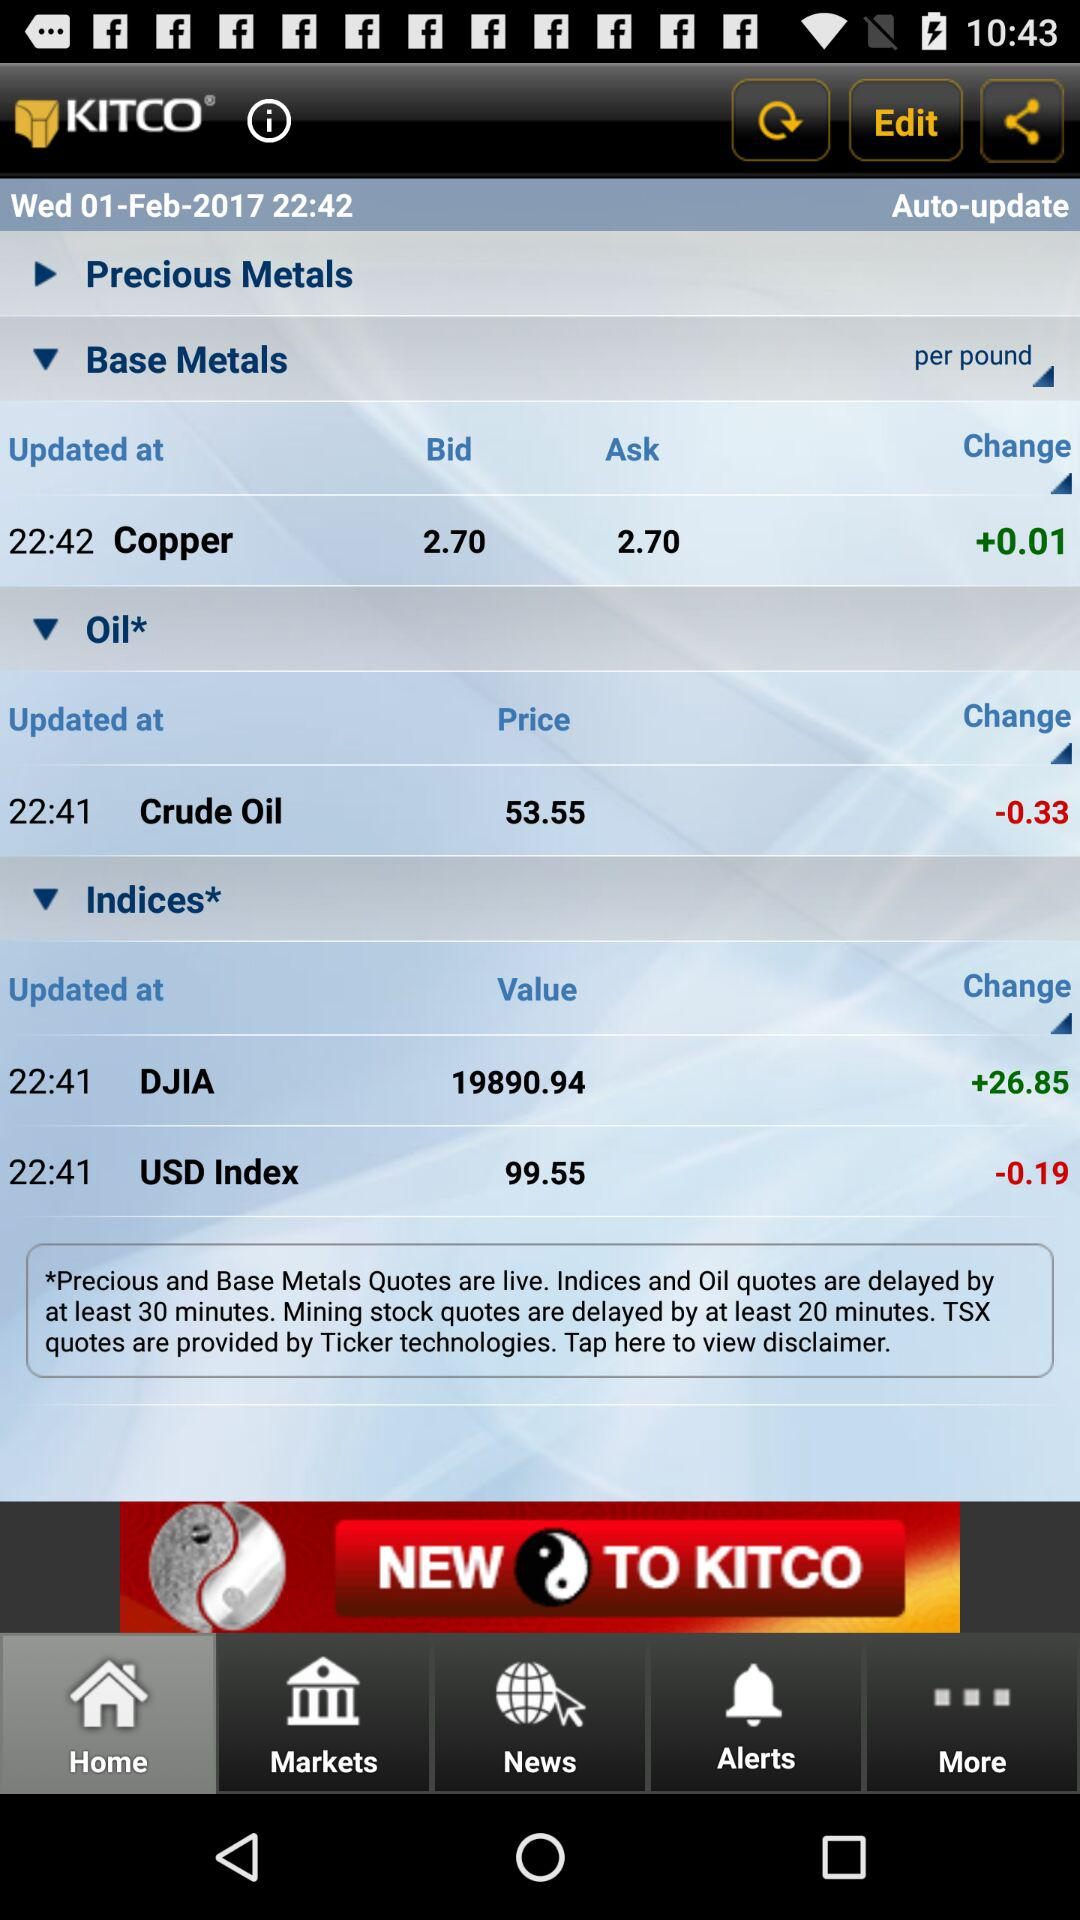What is the application name? The application name is "KITCO". 